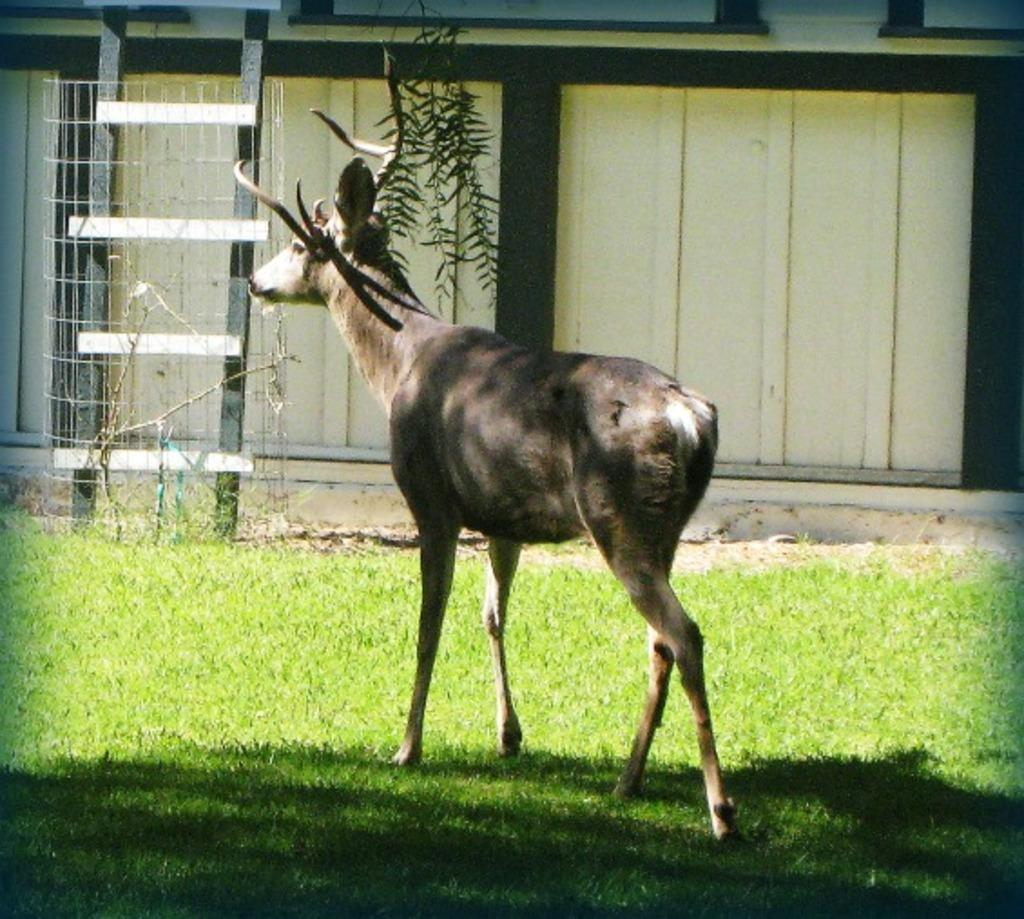What is the primary feature of the land in the image? The land in the image is covered with grass. Can you describe the animal in the image? There is an animal in the image, facing towards the left side. What can be seen in the background of the image? There is a mesh, a ladder, and a wall in the background of the image. What is the temper of the ant in the image? There is no ant present in the image, so it is not possible to determine its temper. 